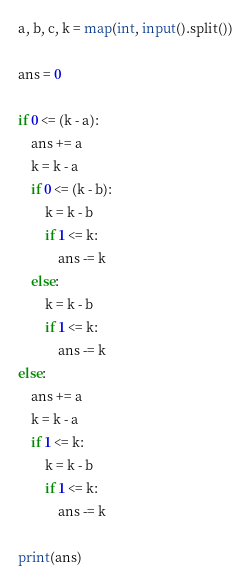Convert code to text. <code><loc_0><loc_0><loc_500><loc_500><_Python_>a, b, c, k = map(int, input().split())

ans = 0

if 0 <= (k - a):
    ans += a
    k = k - a
    if 0 <= (k - b):
        k = k - b
        if 1 <= k:
            ans -= k
    else:
        k = k - b
        if 1 <= k:
            ans -= k
else:
    ans += a
    k = k - a
    if 1 <= k:
        k = k - b
        if 1 <= k:
            ans -= k

print(ans)</code> 